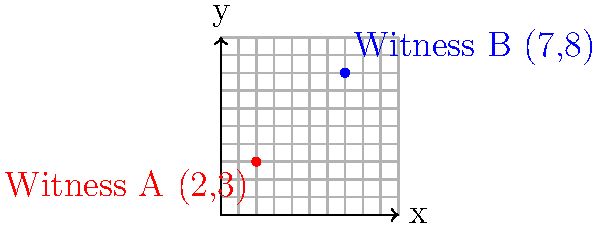In a recent crime scene investigation, two key witnesses were positioned at different locations. Witness A was located at coordinates (2,3), and Witness B was at coordinates (7,8) on the crime scene grid. As part of your preparation for the prosecutor's case, you need to calculate the exact distance between these two witnesses. Using the distance formula, determine the distance between Witness A and Witness B to the nearest hundredth of a unit. To solve this problem, we'll use the distance formula derived from the Pythagorean theorem:

$$ d = \sqrt{(x_2 - x_1)^2 + (y_2 - y_1)^2} $$

Where $(x_1, y_1)$ are the coordinates of the first point and $(x_2, y_2)$ are the coordinates of the second point.

Step 1: Identify the coordinates
- Witness A: $(x_1, y_1) = (2, 3)$
- Witness B: $(x_2, y_2) = (7, 8)$

Step 2: Plug the coordinates into the distance formula
$$ d = \sqrt{(7 - 2)^2 + (8 - 3)^2} $$

Step 3: Simplify the expressions inside the parentheses
$$ d = \sqrt{5^2 + 5^2} $$

Step 4: Calculate the squares
$$ d = \sqrt{25 + 25} $$

Step 5: Add the values under the square root
$$ d = \sqrt{50} $$

Step 6: Simplify the square root
$$ d = 5\sqrt{2} \approx 7.0710678118 $$

Step 7: Round to the nearest hundredth
$$ d \approx 7.07 \text{ units} $$
Answer: 7.07 units 